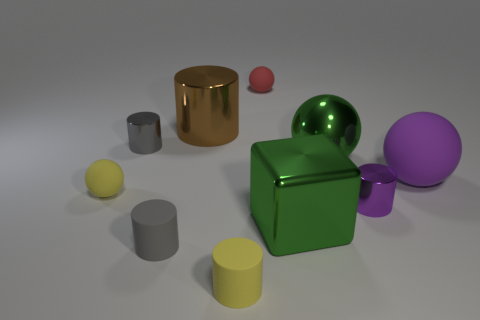What number of things are small gray cylinders that are behind the purple rubber sphere or purple shiny cylinders?
Make the answer very short. 2. There is a matte ball that is right of the tiny metallic thing right of the rubber cylinder that is in front of the tiny gray rubber object; how big is it?
Provide a succinct answer. Large. There is a thing that is the same color as the big block; what material is it?
Keep it short and to the point. Metal. Are there any other things that are the same shape as the purple rubber thing?
Offer a terse response. Yes. What size is the sphere in front of the matte thing right of the large green cube?
Provide a short and direct response. Small. What number of big objects are either rubber blocks or brown metallic things?
Provide a short and direct response. 1. Is the number of tiny gray metal objects less than the number of big metal things?
Your answer should be compact. Yes. Are there any other things that have the same size as the brown metal object?
Give a very brief answer. Yes. Do the large metal block and the large matte sphere have the same color?
Offer a terse response. No. Is the number of yellow matte cylinders greater than the number of matte objects?
Provide a succinct answer. No. 